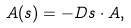<formula> <loc_0><loc_0><loc_500><loc_500>A ( s ) = - D s \cdot A ,</formula> 